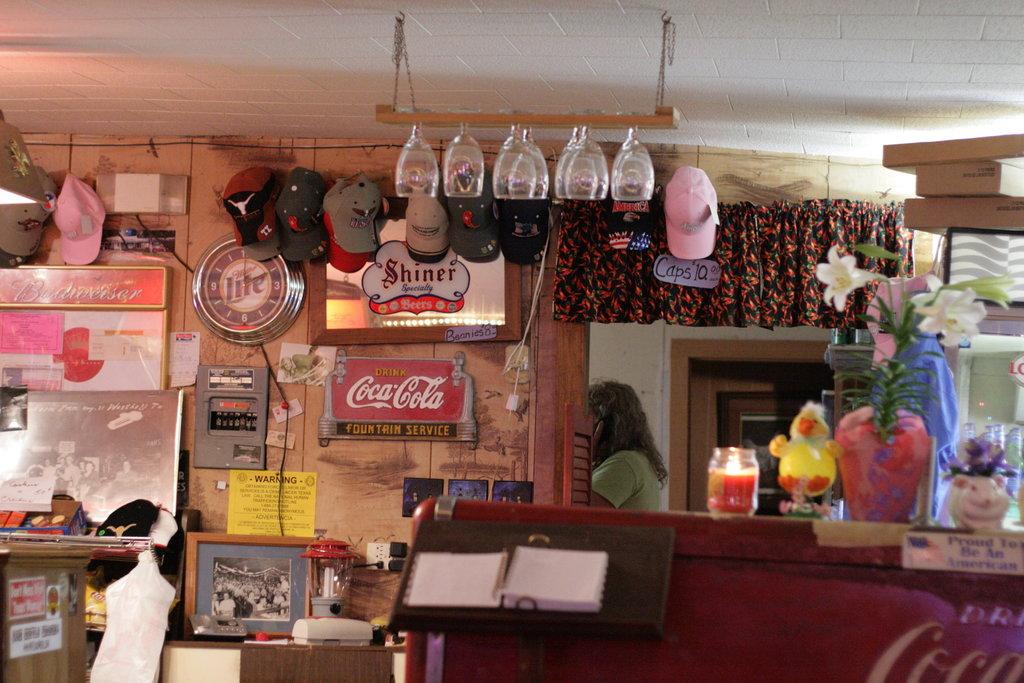Which beer brand is advertised on the clock?
Your answer should be compact. Miller lite. What is the brand on soda on the wall?
Give a very brief answer. Coca cola. 